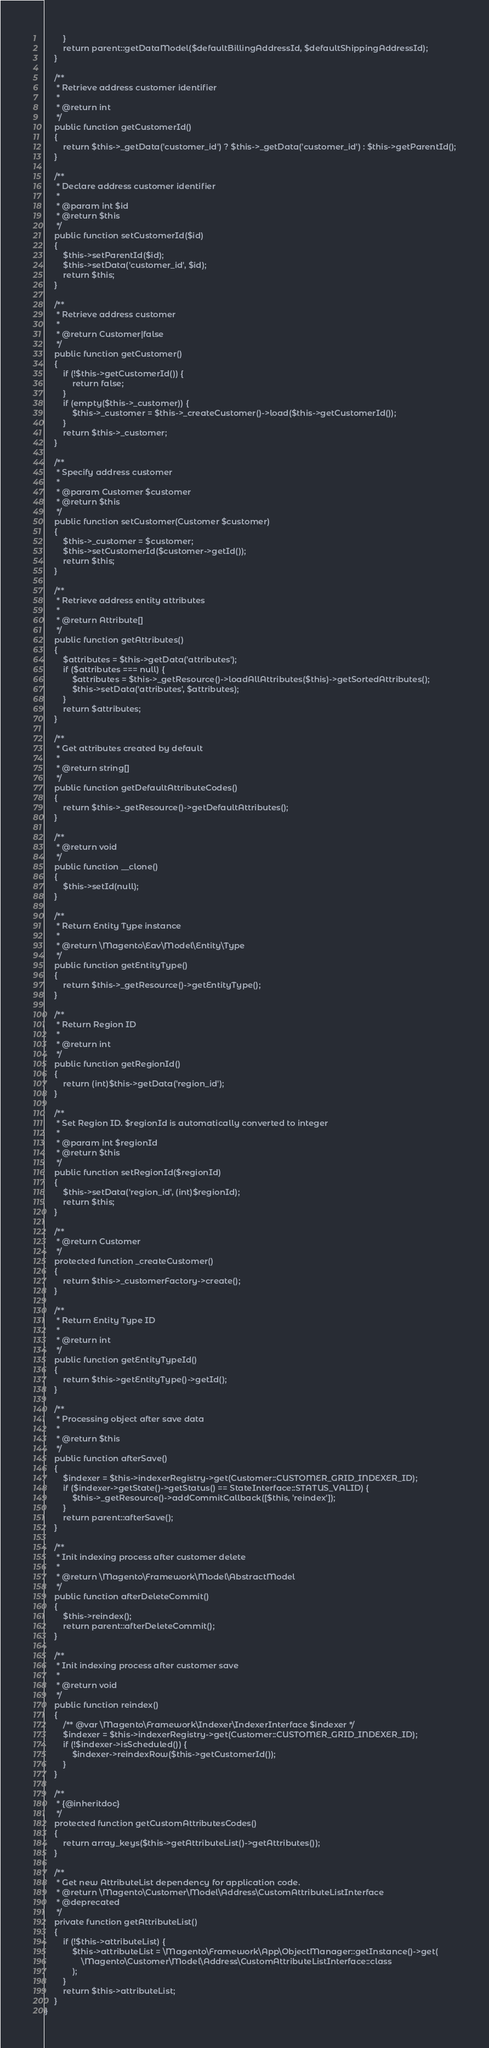<code> <loc_0><loc_0><loc_500><loc_500><_PHP_>        }
        return parent::getDataModel($defaultBillingAddressId, $defaultShippingAddressId);
    }

    /**
     * Retrieve address customer identifier
     *
     * @return int
     */
    public function getCustomerId()
    {
        return $this->_getData('customer_id') ? $this->_getData('customer_id') : $this->getParentId();
    }

    /**
     * Declare address customer identifier
     *
     * @param int $id
     * @return $this
     */
    public function setCustomerId($id)
    {
        $this->setParentId($id);
        $this->setData('customer_id', $id);
        return $this;
    }

    /**
     * Retrieve address customer
     *
     * @return Customer|false
     */
    public function getCustomer()
    {
        if (!$this->getCustomerId()) {
            return false;
        }
        if (empty($this->_customer)) {
            $this->_customer = $this->_createCustomer()->load($this->getCustomerId());
        }
        return $this->_customer;
    }

    /**
     * Specify address customer
     *
     * @param Customer $customer
     * @return $this
     */
    public function setCustomer(Customer $customer)
    {
        $this->_customer = $customer;
        $this->setCustomerId($customer->getId());
        return $this;
    }

    /**
     * Retrieve address entity attributes
     *
     * @return Attribute[]
     */
    public function getAttributes()
    {
        $attributes = $this->getData('attributes');
        if ($attributes === null) {
            $attributes = $this->_getResource()->loadAllAttributes($this)->getSortedAttributes();
            $this->setData('attributes', $attributes);
        }
        return $attributes;
    }

    /**
     * Get attributes created by default
     *
     * @return string[]
     */
    public function getDefaultAttributeCodes()
    {
        return $this->_getResource()->getDefaultAttributes();
    }

    /**
     * @return void
     */
    public function __clone()
    {
        $this->setId(null);
    }

    /**
     * Return Entity Type instance
     *
     * @return \Magento\Eav\Model\Entity\Type
     */
    public function getEntityType()
    {
        return $this->_getResource()->getEntityType();
    }

    /**
     * Return Region ID
     *
     * @return int
     */
    public function getRegionId()
    {
        return (int)$this->getData('region_id');
    }

    /**
     * Set Region ID. $regionId is automatically converted to integer
     *
     * @param int $regionId
     * @return $this
     */
    public function setRegionId($regionId)
    {
        $this->setData('region_id', (int)$regionId);
        return $this;
    }

    /**
     * @return Customer
     */
    protected function _createCustomer()
    {
        return $this->_customerFactory->create();
    }

    /**
     * Return Entity Type ID
     *
     * @return int
     */
    public function getEntityTypeId()
    {
        return $this->getEntityType()->getId();
    }

    /**
     * Processing object after save data
     *
     * @return $this
     */
    public function afterSave()
    {
        $indexer = $this->indexerRegistry->get(Customer::CUSTOMER_GRID_INDEXER_ID);
        if ($indexer->getState()->getStatus() == StateInterface::STATUS_VALID) {
            $this->_getResource()->addCommitCallback([$this, 'reindex']);
        }
        return parent::afterSave();
    }

    /**
     * Init indexing process after customer delete
     *
     * @return \Magento\Framework\Model\AbstractModel
     */
    public function afterDeleteCommit()
    {
        $this->reindex();
        return parent::afterDeleteCommit();
    }

    /**
     * Init indexing process after customer save
     *
     * @return void
     */
    public function reindex()
    {
        /** @var \Magento\Framework\Indexer\IndexerInterface $indexer */
        $indexer = $this->indexerRegistry->get(Customer::CUSTOMER_GRID_INDEXER_ID);
        if (!$indexer->isScheduled()) {
            $indexer->reindexRow($this->getCustomerId());
        }
    }

    /**
     * {@inheritdoc}
     */
    protected function getCustomAttributesCodes()
    {
        return array_keys($this->getAttributeList()->getAttributes());
    }

    /**
     * Get new AttributeList dependency for application code.
     * @return \Magento\Customer\Model\Address\CustomAttributeListInterface
     * @deprecated
     */
    private function getAttributeList()
    {
        if (!$this->attributeList) {
            $this->attributeList = \Magento\Framework\App\ObjectManager::getInstance()->get(
                \Magento\Customer\Model\Address\CustomAttributeListInterface::class
            );
        }
        return $this->attributeList;
    }
}
</code> 